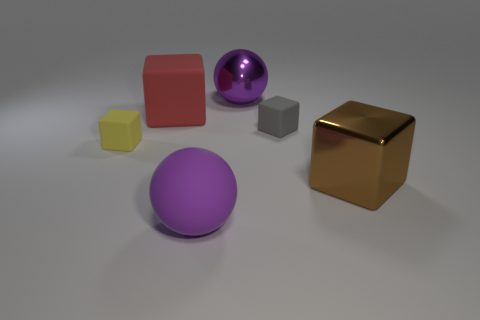Subtract all small gray matte cubes. How many cubes are left? 3 Subtract all red blocks. How many blocks are left? 3 Add 1 gray matte blocks. How many objects exist? 7 Subtract all purple cubes. Subtract all blue spheres. How many cubes are left? 4 Subtract all blocks. How many objects are left? 2 Subtract all big purple shiny objects. Subtract all gray things. How many objects are left? 4 Add 2 small rubber blocks. How many small rubber blocks are left? 4 Add 3 big red matte balls. How many big red matte balls exist? 3 Subtract 1 brown cubes. How many objects are left? 5 